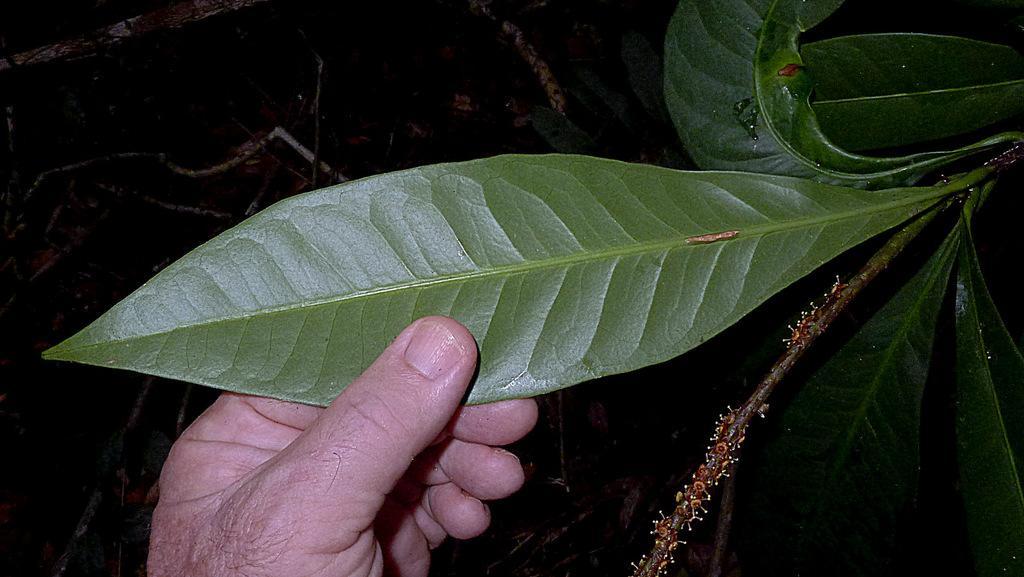Please provide a concise description of this image. In this image we can see the hand of a person holding the leaf. 